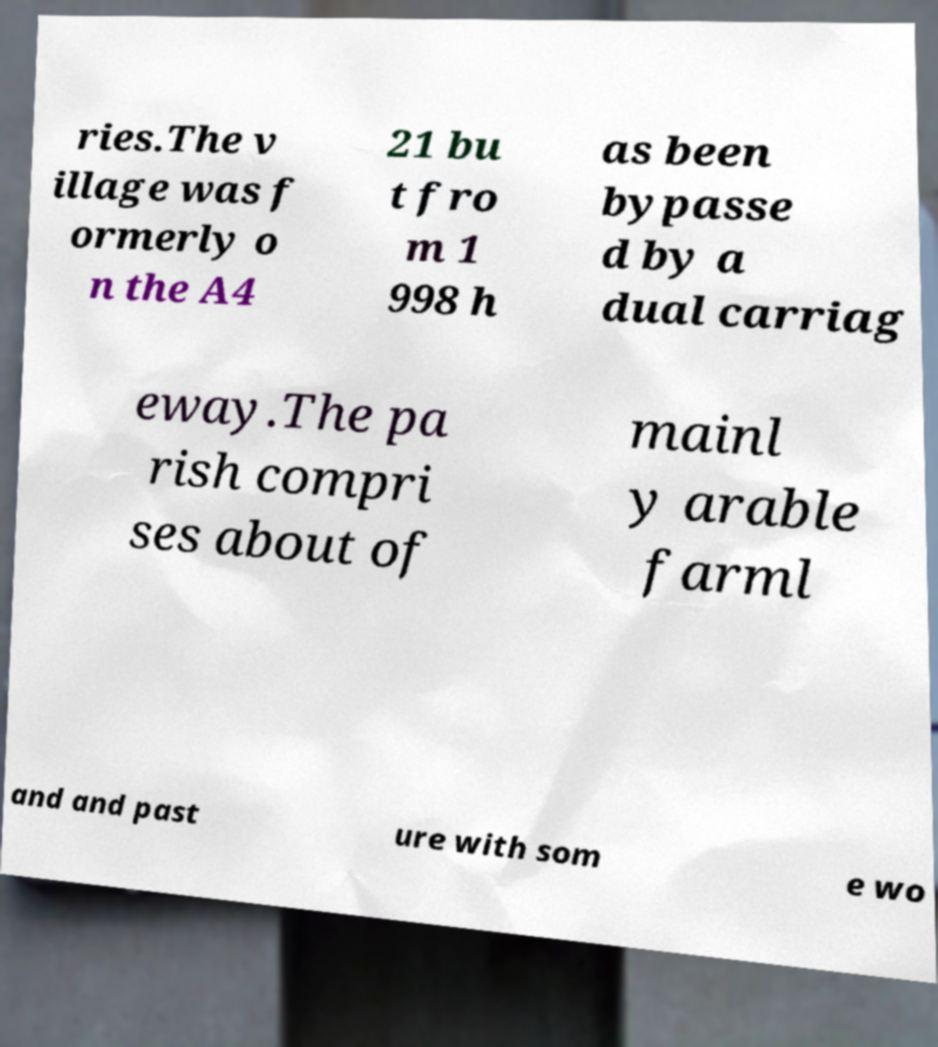Could you assist in decoding the text presented in this image and type it out clearly? ries.The v illage was f ormerly o n the A4 21 bu t fro m 1 998 h as been bypasse d by a dual carriag eway.The pa rish compri ses about of mainl y arable farml and and past ure with som e wo 